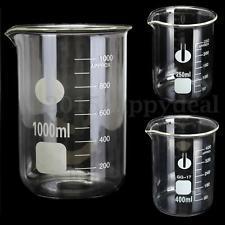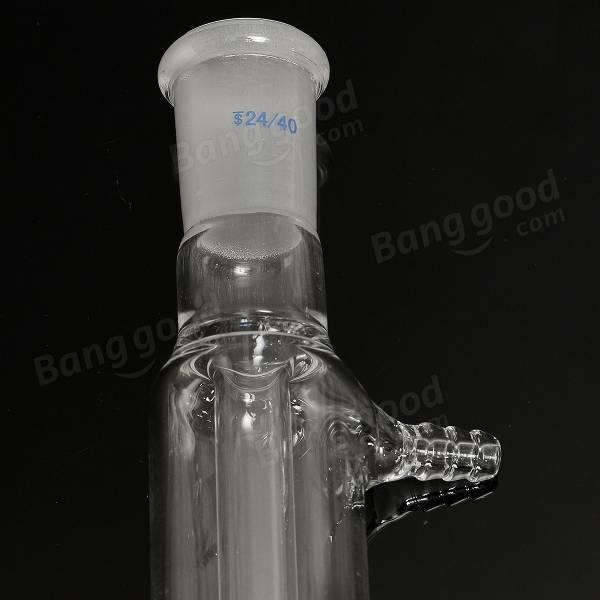The first image is the image on the left, the second image is the image on the right. Assess this claim about the two images: "There are exactly three flasks in the image on the left.". Correct or not? Answer yes or no. Yes. 